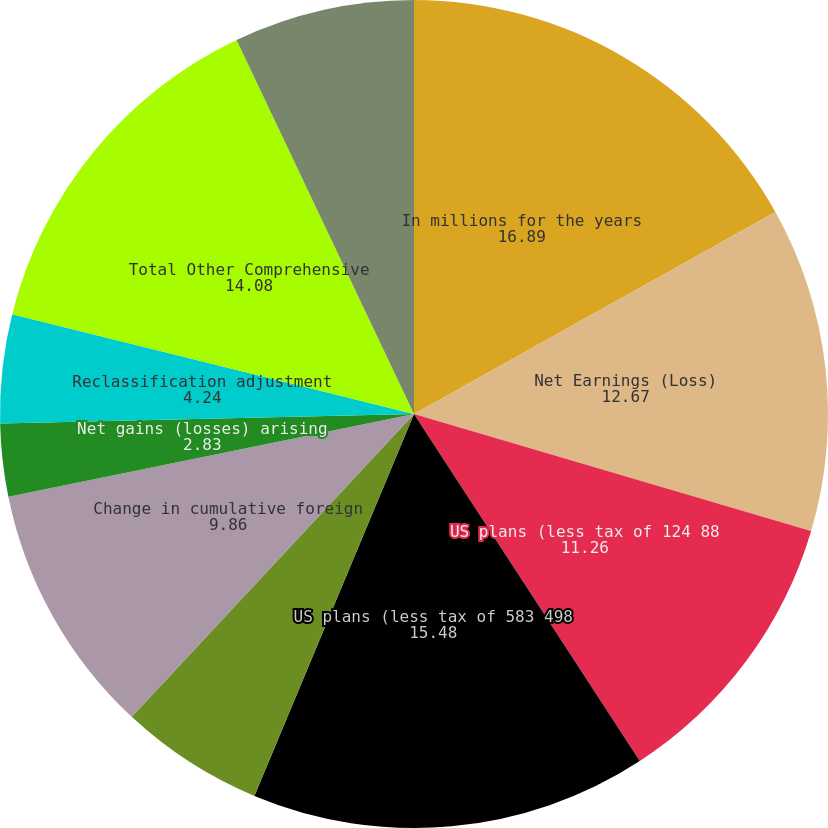Convert chart. <chart><loc_0><loc_0><loc_500><loc_500><pie_chart><fcel>In millions for the years<fcel>Net Earnings (Loss)<fcel>US plans (less tax of 124 88<fcel>US plans (less tax of 583 498<fcel>Non-US plans (less tax of 9 3<fcel>Change in cumulative foreign<fcel>Net gains (losses) arising<fcel>Reclassification adjustment<fcel>Total Other Comprehensive<fcel>Comprehensive Income (Loss)<nl><fcel>16.89%<fcel>12.67%<fcel>11.26%<fcel>15.48%<fcel>5.64%<fcel>9.86%<fcel>2.83%<fcel>4.24%<fcel>14.08%<fcel>7.05%<nl></chart> 